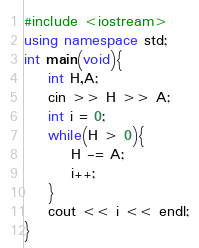Convert code to text. <code><loc_0><loc_0><loc_500><loc_500><_C++_>#include <iostream>
using namespace std;
int main(void){
    int H,A;
    cin >> H >> A;
    int i = 0;
    while(H > 0){
        H -= A;
        i++;
    }
    cout << i << endl;
}
</code> 